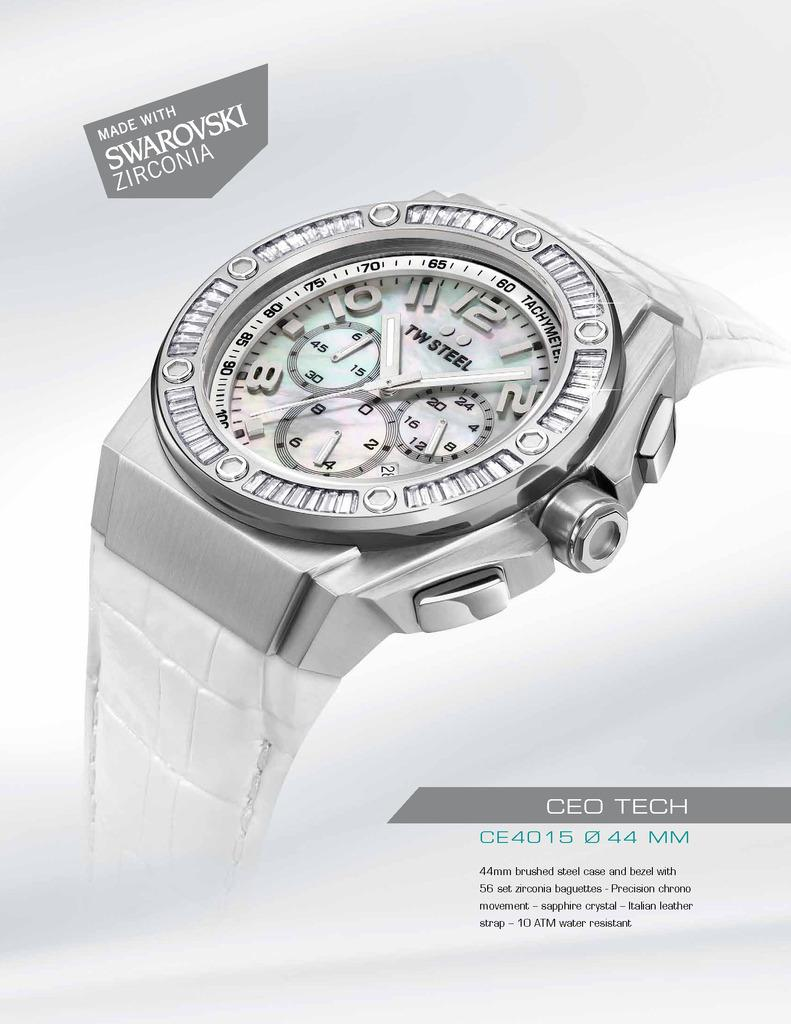Provide a one-sentence caption for the provided image. CEO Tech is displayed to the lower right of a silver watch. 